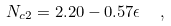Convert formula to latex. <formula><loc_0><loc_0><loc_500><loc_500>N _ { c 2 } = 2 . 2 0 - 0 . 5 7 \epsilon \ \ ,</formula> 